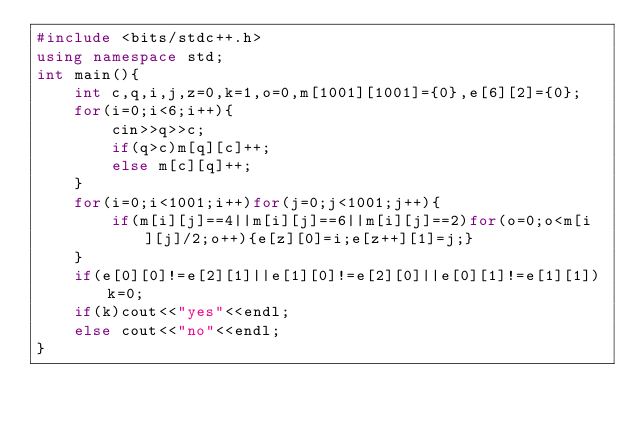<code> <loc_0><loc_0><loc_500><loc_500><_C++_>#include <bits/stdc++.h>
using namespace std;
int main(){
	int c,q,i,j,z=0,k=1,o=0,m[1001][1001]={0},e[6][2]={0};
	for(i=0;i<6;i++){
		cin>>q>>c;
		if(q>c)m[q][c]++;
		else m[c][q]++;
	}
	for(i=0;i<1001;i++)for(j=0;j<1001;j++){
		if(m[i][j]==4||m[i][j]==6||m[i][j]==2)for(o=0;o<m[i][j]/2;o++){e[z][0]=i;e[z++][1]=j;}
	}
	if(e[0][0]!=e[2][1]||e[1][0]!=e[2][0]||e[0][1]!=e[1][1])k=0;
	if(k)cout<<"yes"<<endl;
	else cout<<"no"<<endl;
}</code> 